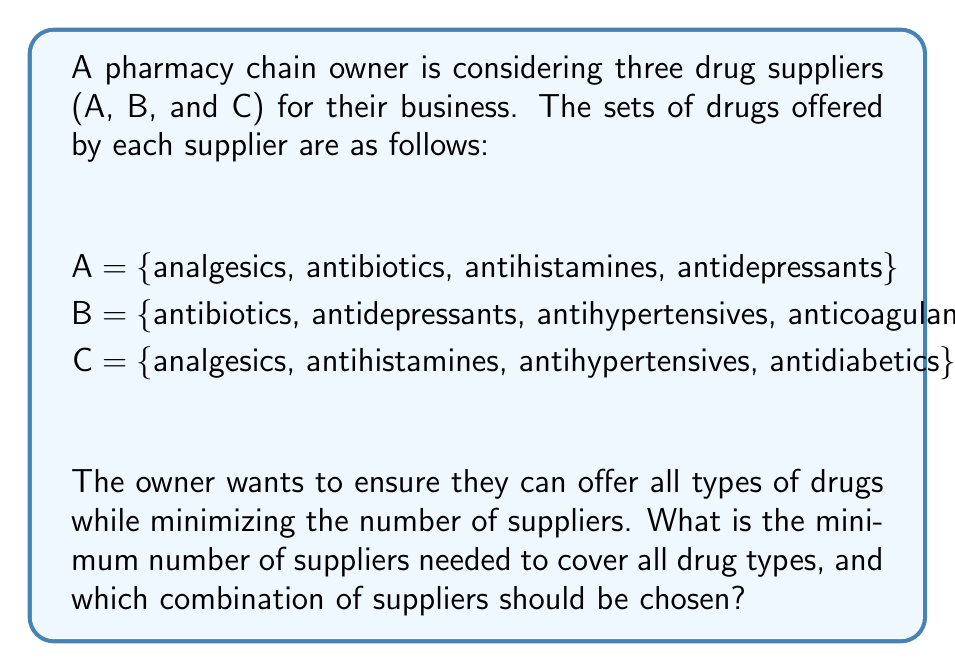Solve this math problem. To solve this problem, we need to use set operations to determine the optimal combination of suppliers. Let's approach this step-by-step:

1. First, let's list all the unique drug types across all suppliers:
   $$ U = A \cup B \cup C $$
   $$ U = \text{\{analgesics, antibiotics, antihistamines, antidepressants, antihypertensives, anticoagulants, antidiabetics\}} $$

2. Now, we need to find the combination of suppliers that covers all these drug types with the minimum number of suppliers.

3. Let's start by checking if any two suppliers can cover all drug types:

   A ∪ B = {analgesics, antibiotics, antihistamines, antidepressants, antihypertensives, anticoagulants}
   A ∪ C = {analgesics, antibiotics, antihistamines, antidepressants, antihypertensives, antidiabetics}
   B ∪ C = {antibiotics, antidepressants, antihypertensives, anticoagulants, analgesics, antihistamines, antidiabetics}

4. We can see that B ∪ C covers all drug types in U.

5. Therefore, the minimum number of suppliers needed is 2, and the optimal combination is suppliers B and C.

This combination ensures that all drug types are available while minimizing the number of suppliers, which can lead to better negotiation power and potentially lower costs for the pharmacy chain.
Answer: The minimum number of suppliers needed is 2, and the optimal combination is suppliers B and C. 